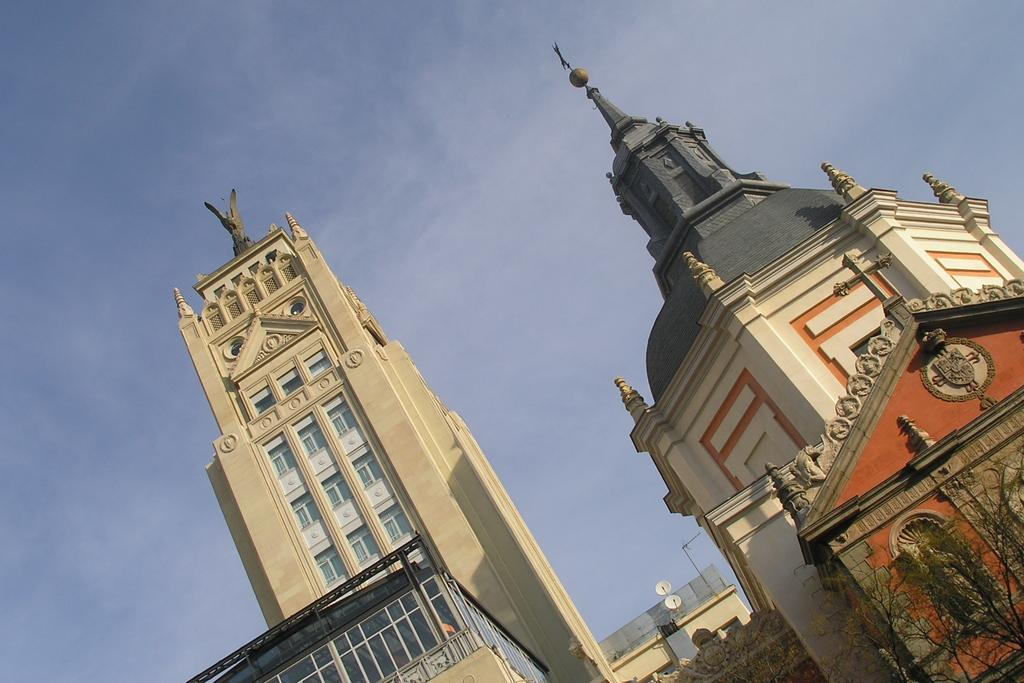What type of structures can be seen in the image? There are buildings in the image. Where are the trees located in the image? The trees are at the right bottom of the image. What communication devices are present in the image? There are satellite dishes in the image. What is visible at the top of the image? The sky is visible at the top of the image. What type of trade is being conducted in the image? There is no indication of trade in the image; it primarily features buildings, trees, satellite dishes, and the sky. 